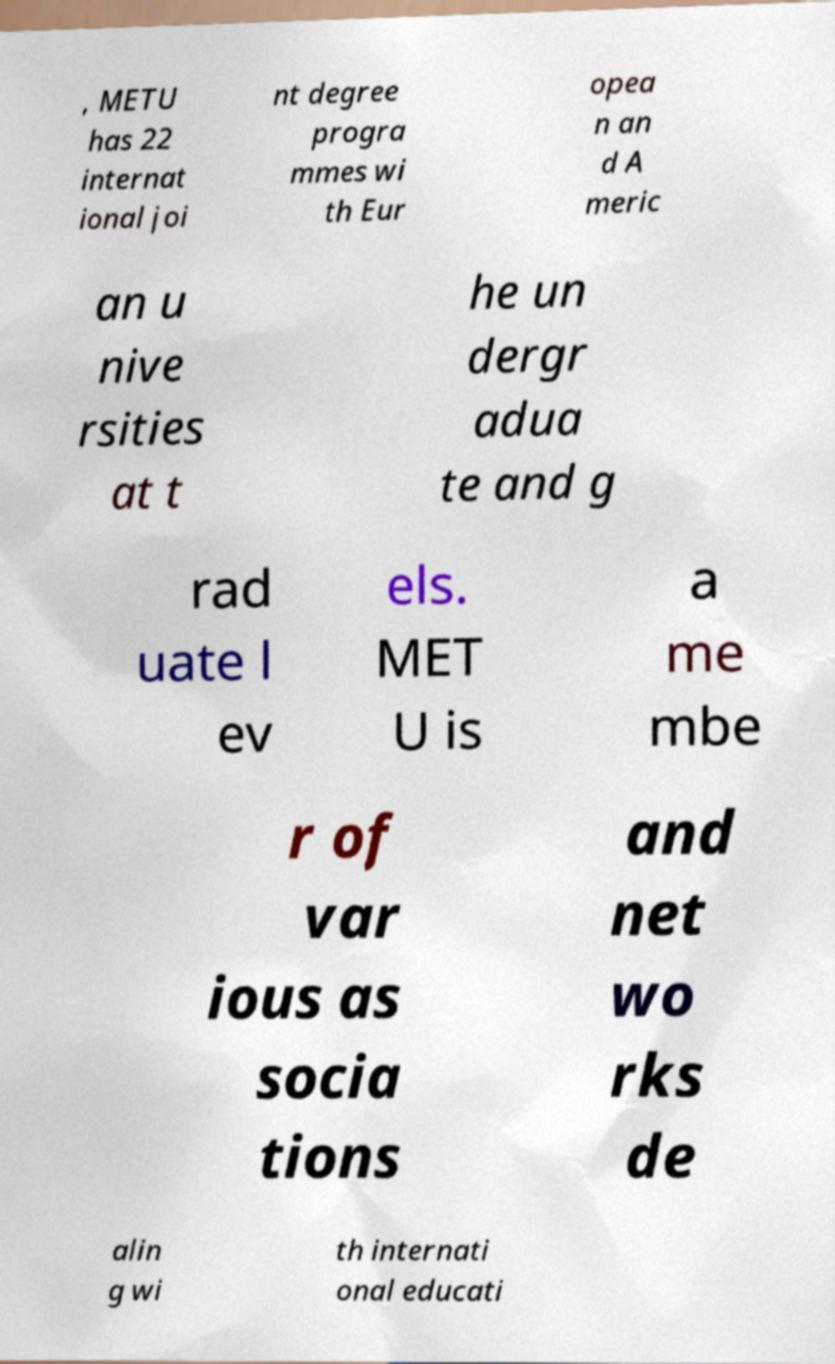For documentation purposes, I need the text within this image transcribed. Could you provide that? , METU has 22 internat ional joi nt degree progra mmes wi th Eur opea n an d A meric an u nive rsities at t he un dergr adua te and g rad uate l ev els. MET U is a me mbe r of var ious as socia tions and net wo rks de alin g wi th internati onal educati 